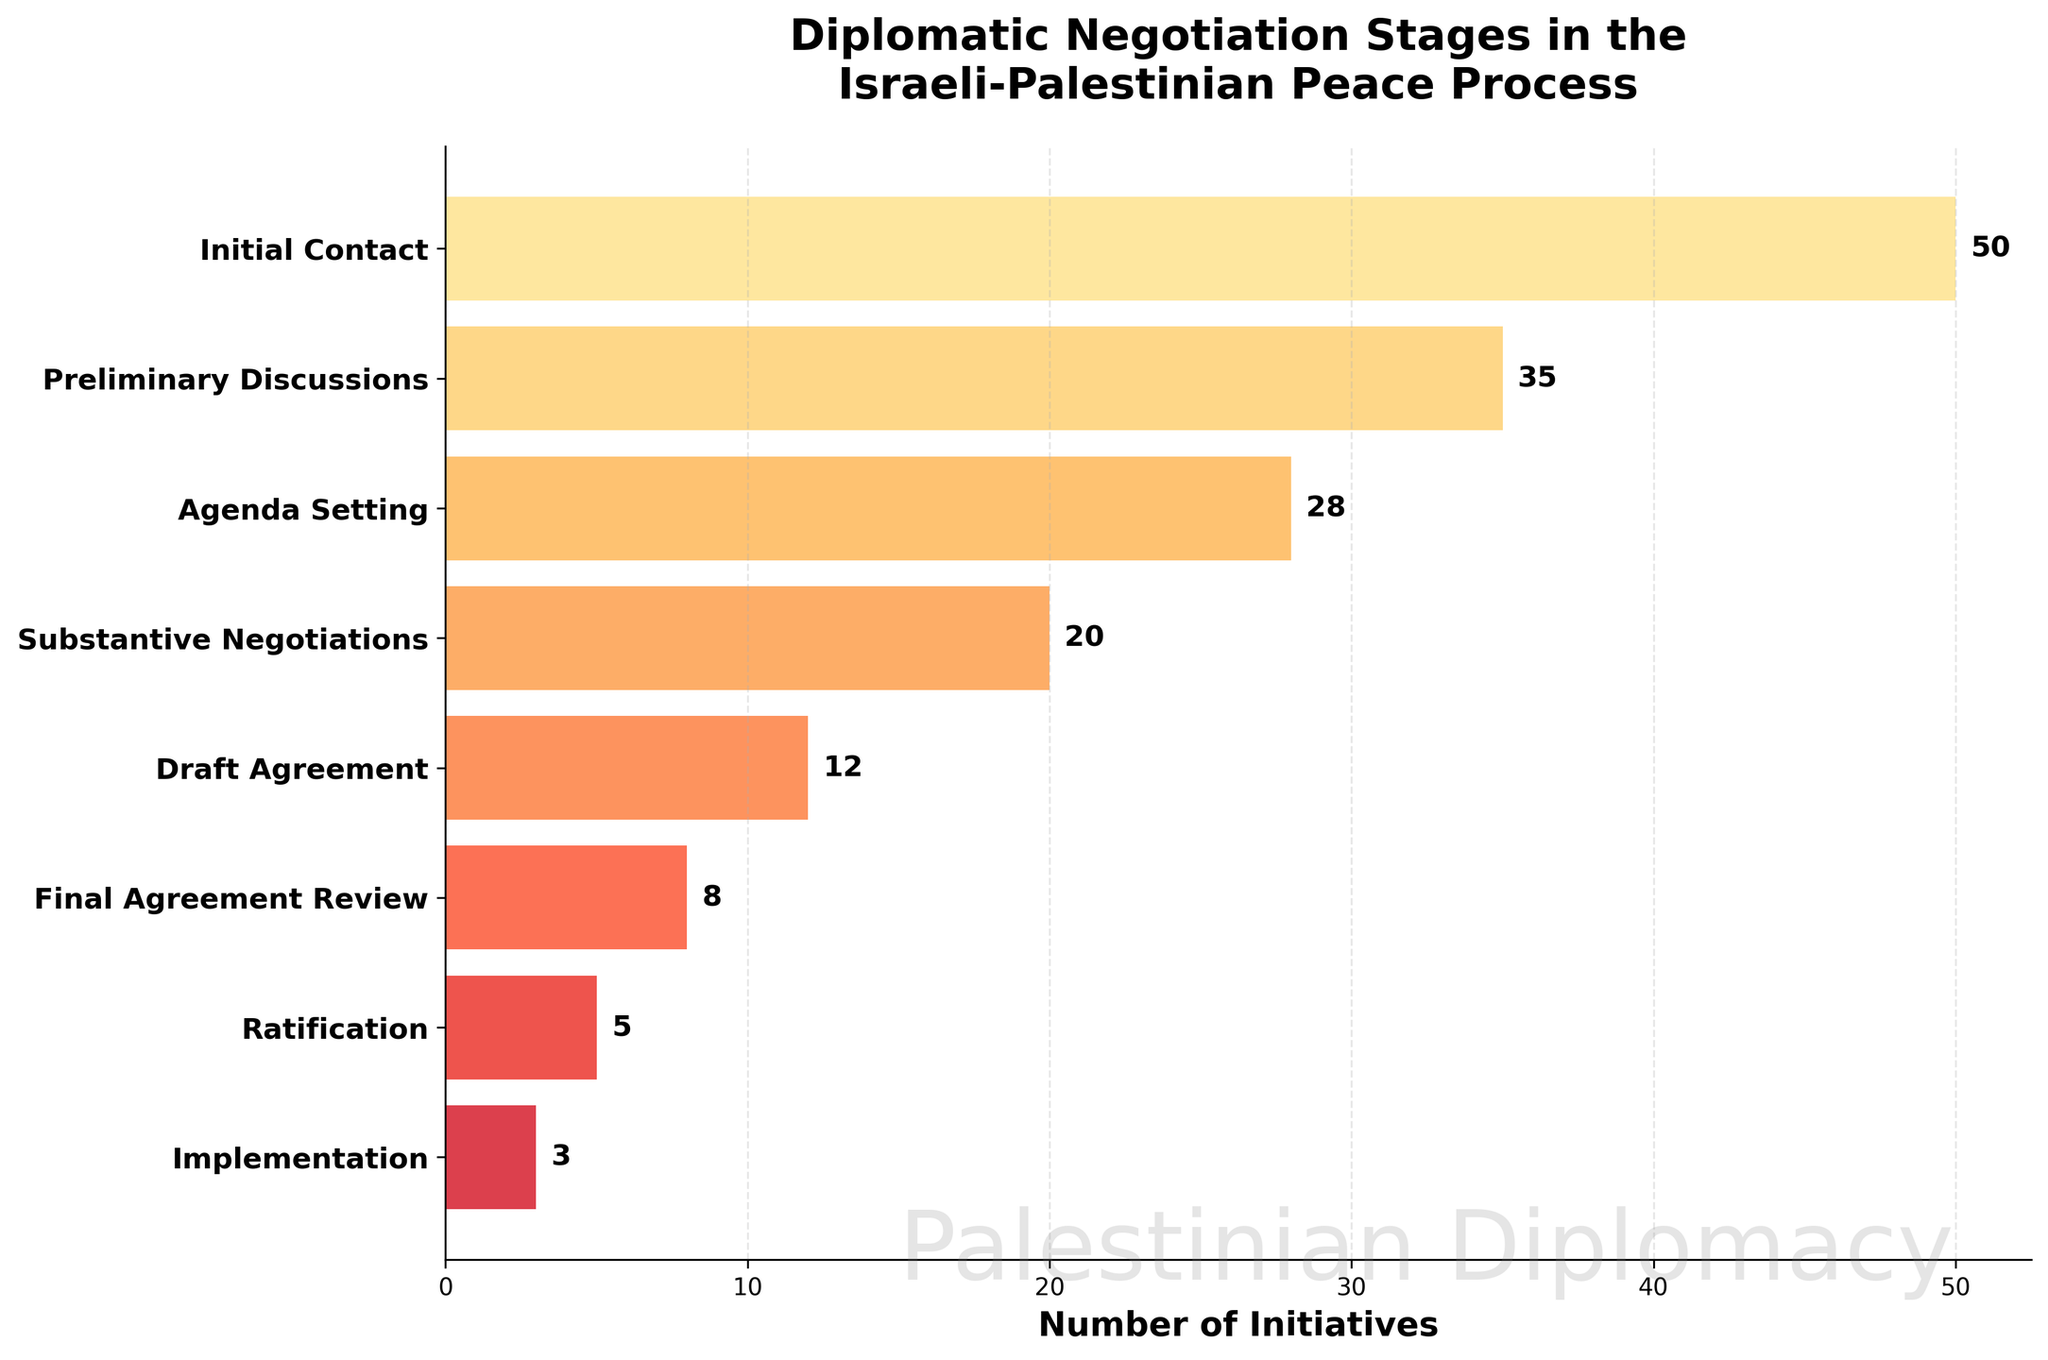Which stage has the highest number of initiatives? The highest bar in the funnel chart represents the Initial Contact stage with the largest width.
Answer: Initial Contact How many stages are there in the diplomatic negotiation process? Count the number of distinct stages listed along the y-axis in the funnel chart. There are eight stages.
Answer: Eight What is the difference in the number of initiatives between Agenda Setting and Draft Agreement stages? Subtract the number of initiatives in the Draft Agreement (12) from those in Agenda Setting (28). 28 - 12 = 16.
Answer: 16 Which stage comes directly before the Final Agreement Review? Referring to the order of the stages on the y-axis, the stage before Final Agreement Review is Draft Agreement.
Answer: Draft Agreement What is the total number of initiatives from Draft Agreement to Implementation stages? Sum the number of initiatives from Draft Agreement (12), Final Agreement Review (8), Ratification (5), and Implementation (3). 12 + 8 + 5 + 3 = 28.
Answer: 28 What percentage of initiatives reach the Ratification stage out of the Initial Contact stage? Calculate the percentage by dividing the number of initiatives in Ratification (5) by those in Initial Contact (50) and multiplying by 100. (5 / 50) * 100 = 10%.
Answer: 10% Which stage sees the largest drop in the number of initiatives? Compare the decrease in the number of initiatives between each consecutive stage and find the largest difference. The drop from Preliminary Discussions (35) to Agenda Setting (28) is 7, which is the largest.
Answer: Preliminary Discussions to Agenda Setting Between which stages does the number of initiatives remain the same? There is no stage where the number of initiatives remains the same because each stage shows a decrease.
Answer: None Is the number of initiatives reduced by more than half from Initial Contact to Final Agreement Review? Compare the initiatives in Initial Contact (50) to those in Final Agreement Review (8). 50 / 2 = 25, and 8 is less than 25, so yes, it is reduced by more than half.
Answer: Yes Which three stages have the fewest number of initiatives? Identify the stages with the three smallest bars: Implementation (3), Ratification (5), and Final Agreement Review (8).
Answer: Implementation, Ratification, Final Agreement Review 